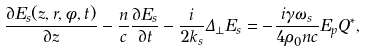<formula> <loc_0><loc_0><loc_500><loc_500>\ { \frac { \partial { { E _ { s } } ( z , r , \phi , t ) } } { \partial z } } - { \frac { n } { c } } { \frac { \partial { E _ { s } } } { \partial t } } - { \frac { i } { 2 k _ { s } } } \Delta _ { \bot } { E _ { s } } = - { \frac { i \gamma \omega _ { s } } { 4 { \rho _ { 0 } } n c } } E _ { p } { Q } ^ { \ast } ,</formula> 